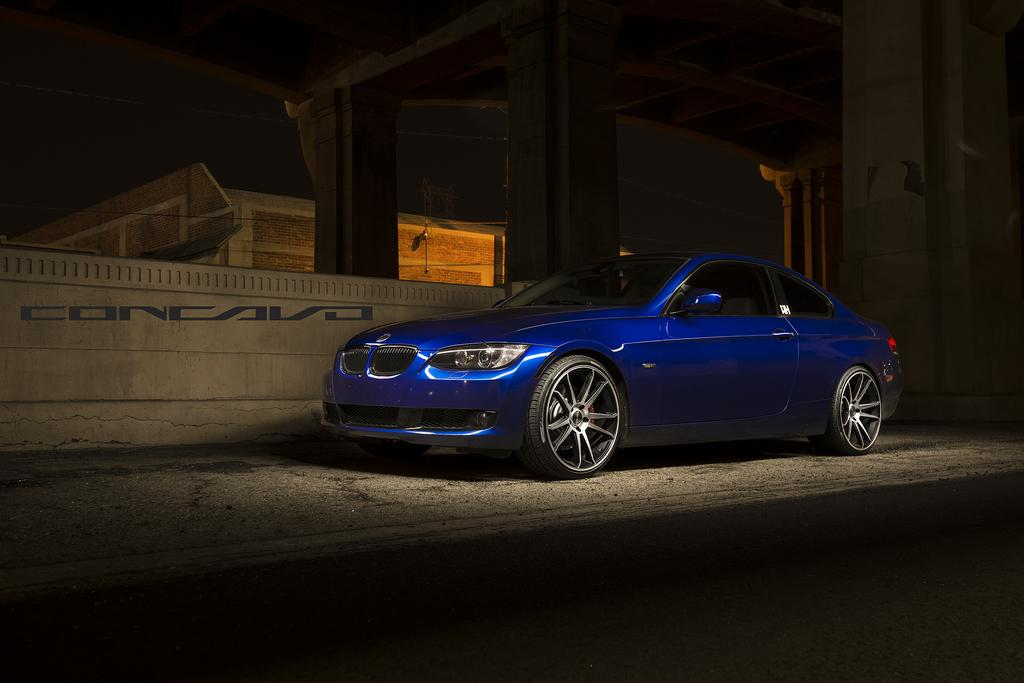What is the lighting condition in the image? The image was taken in the dark. What type of vehicle is on the road in the image? There is a blue color car on the road. What is located on the left side of the image? There is a wall on the left side of the image. What can be seen in the background of the image? There is a building in the background of the image. How many girls are kicking the ball in the image? There are no girls or balls present in the image. 